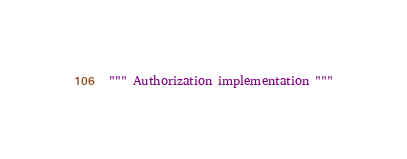Convert code to text. <code><loc_0><loc_0><loc_500><loc_500><_Python_>""" Authorization implementation """
</code> 